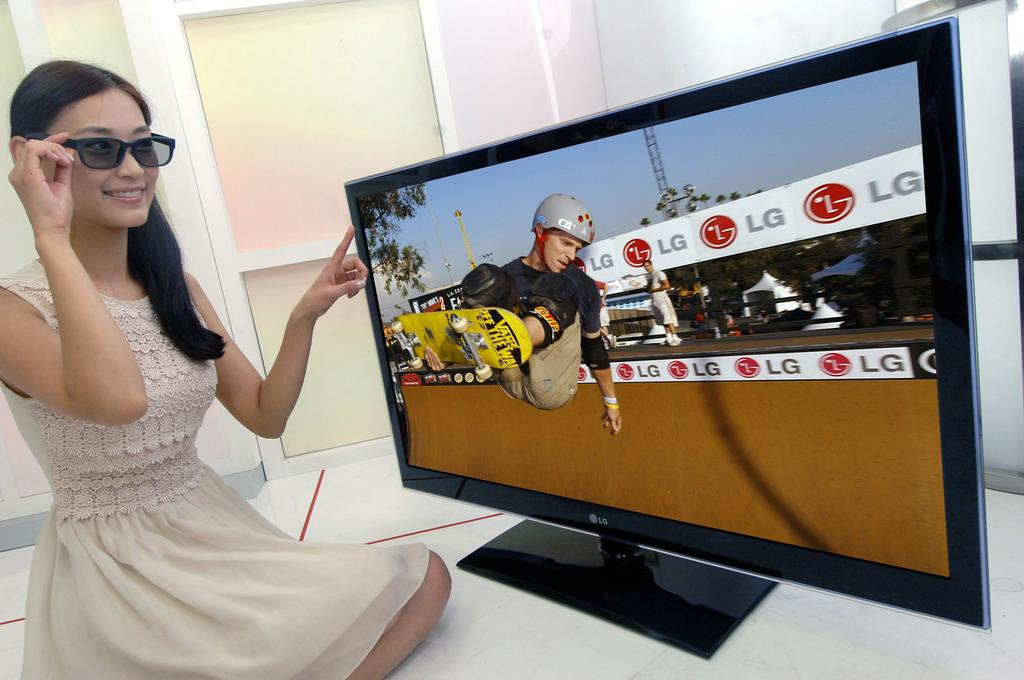<image>
Create a compact narrative representing the image presented. Women pointing and looking at an LG television with a skateboarder that is sponsored by LG. 